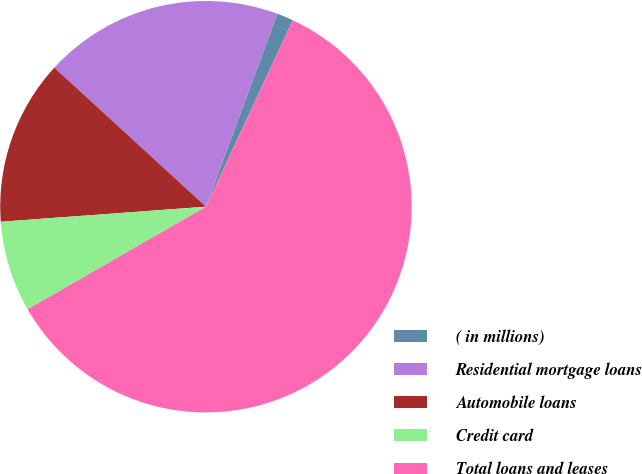Convert chart. <chart><loc_0><loc_0><loc_500><loc_500><pie_chart><fcel>( in millions)<fcel>Residential mortgage loans<fcel>Automobile loans<fcel>Credit card<fcel>Total loans and leases<nl><fcel>1.29%<fcel>18.83%<fcel>12.98%<fcel>7.14%<fcel>59.76%<nl></chart> 